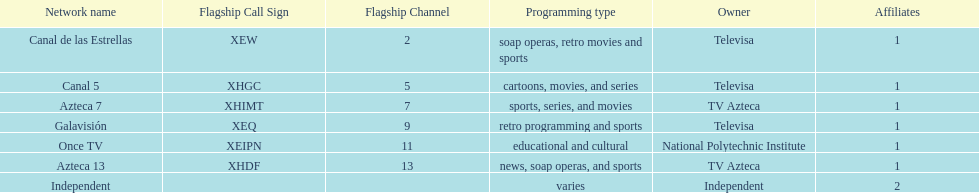How many affiliates does galavision have? 1. 